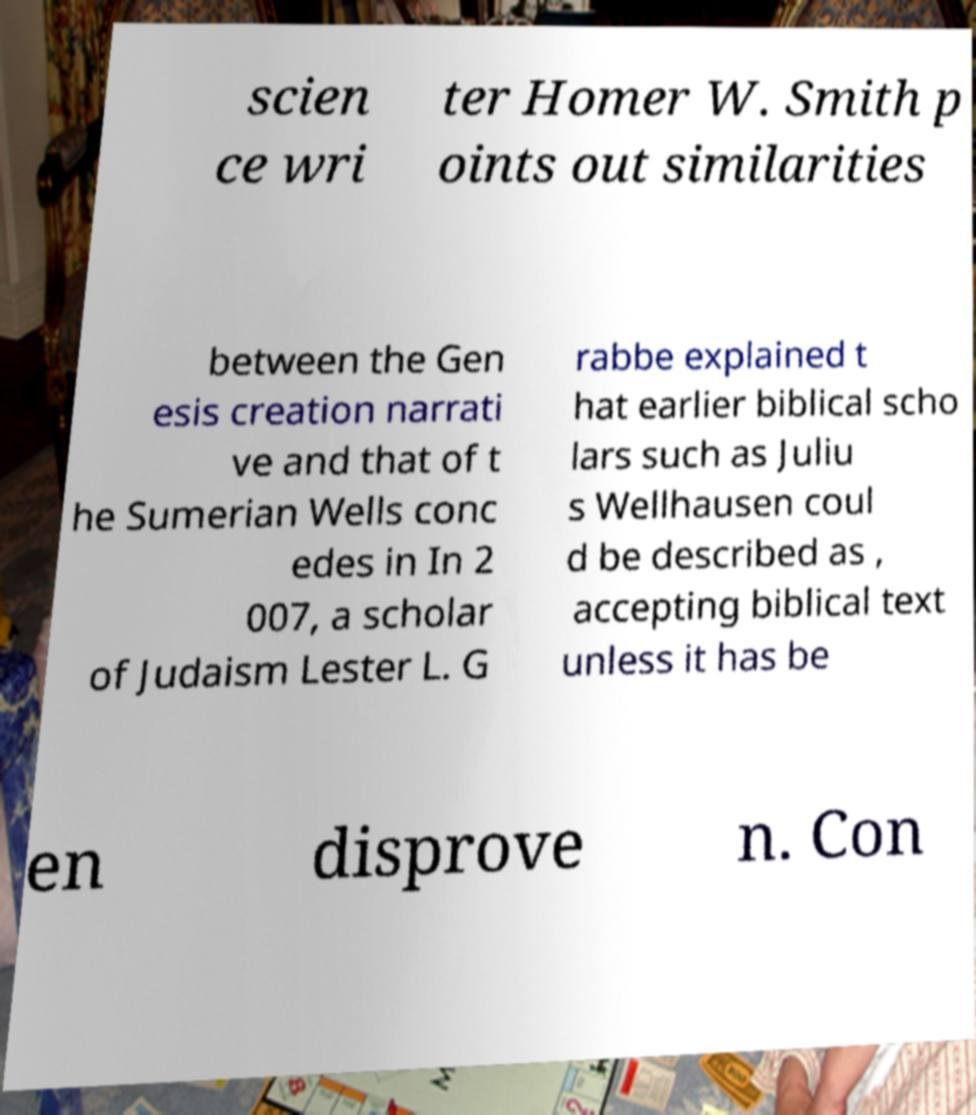Could you assist in decoding the text presented in this image and type it out clearly? scien ce wri ter Homer W. Smith p oints out similarities between the Gen esis creation narrati ve and that of t he Sumerian Wells conc edes in In 2 007, a scholar of Judaism Lester L. G rabbe explained t hat earlier biblical scho lars such as Juliu s Wellhausen coul d be described as , accepting biblical text unless it has be en disprove n. Con 